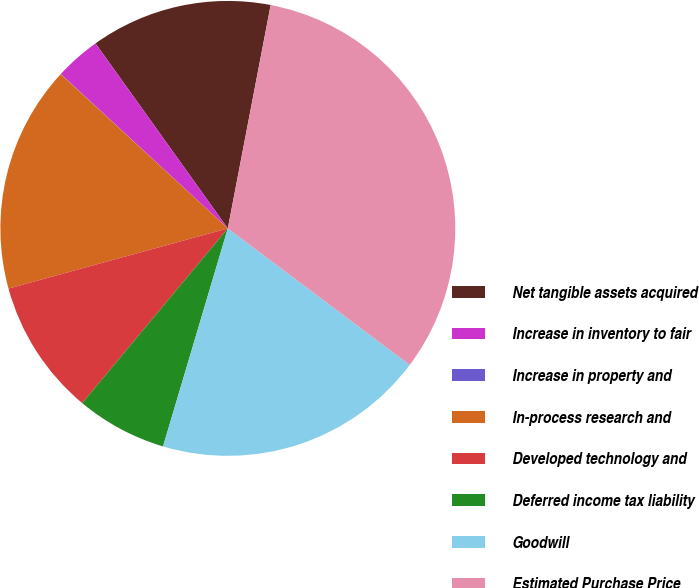<chart> <loc_0><loc_0><loc_500><loc_500><pie_chart><fcel>Net tangible assets acquired<fcel>Increase in inventory to fair<fcel>Increase in property and<fcel>In-process research and<fcel>Developed technology and<fcel>Deferred income tax liability<fcel>Goodwill<fcel>Estimated Purchase Price<nl><fcel>12.9%<fcel>3.24%<fcel>0.02%<fcel>16.12%<fcel>9.68%<fcel>6.46%<fcel>19.35%<fcel>32.23%<nl></chart> 